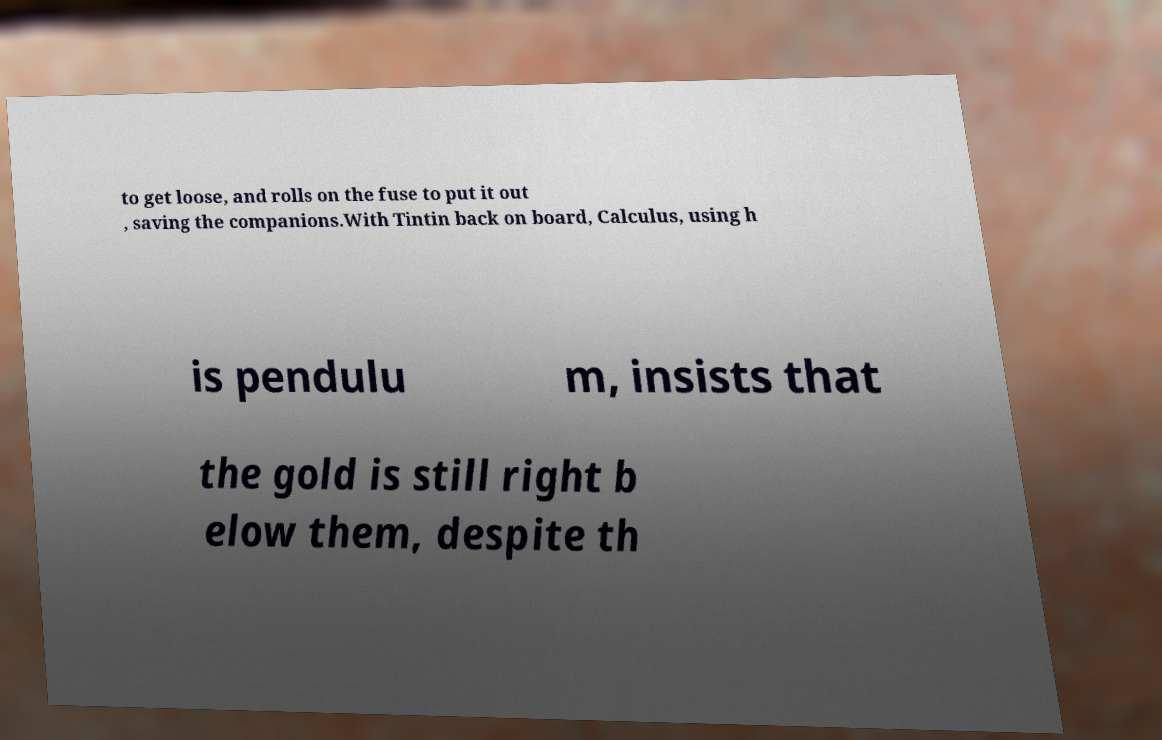Can you accurately transcribe the text from the provided image for me? to get loose, and rolls on the fuse to put it out , saving the companions.With Tintin back on board, Calculus, using h is pendulu m, insists that the gold is still right b elow them, despite th 